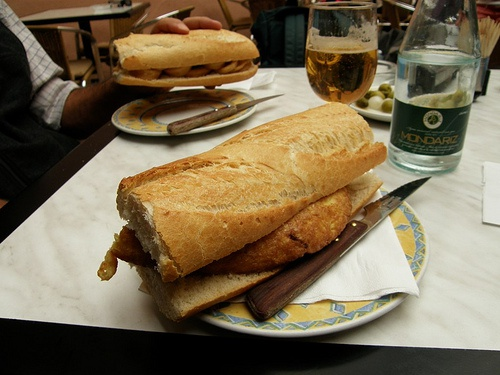Describe the objects in this image and their specific colors. I can see dining table in gray, lightgray, black, and darkgray tones, sandwich in gray, tan, olive, maroon, and black tones, bottle in gray, black, darkgray, and darkgreen tones, people in gray, black, darkgray, and lightgray tones, and people in gray, black, darkgray, and maroon tones in this image. 